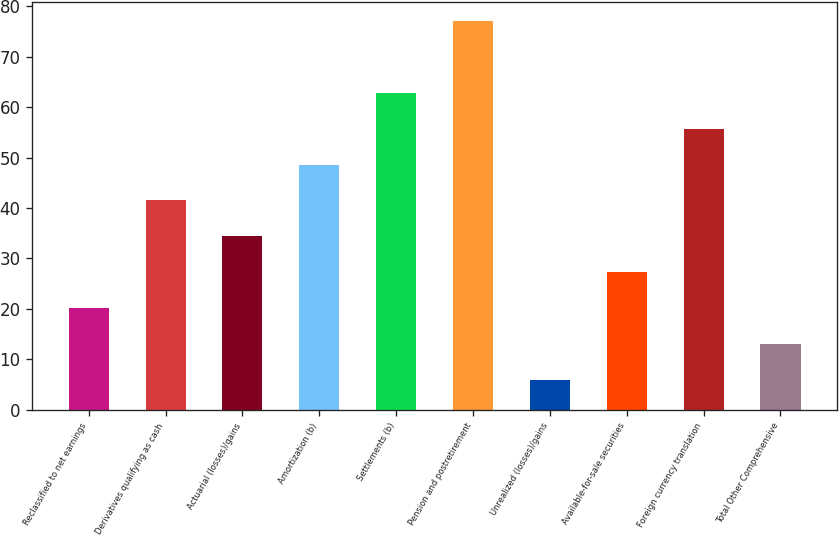Convert chart. <chart><loc_0><loc_0><loc_500><loc_500><bar_chart><fcel>Reclassified to net earnings<fcel>Derivatives qualifying as cash<fcel>Actuarial (losses)/gains<fcel>Amortization (b)<fcel>Settlements (b)<fcel>Pension and postretirement<fcel>Unrealized (losses)/gains<fcel>Available-for-sale securities<fcel>Foreign currency translation<fcel>Total Other Comprehensive<nl><fcel>20.2<fcel>41.5<fcel>34.4<fcel>48.6<fcel>62.8<fcel>77<fcel>6<fcel>27.3<fcel>55.7<fcel>13.1<nl></chart> 